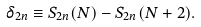<formula> <loc_0><loc_0><loc_500><loc_500>\delta _ { 2 n } \equiv S _ { 2 n } ( N ) - S _ { 2 n } ( N + 2 ) .</formula> 